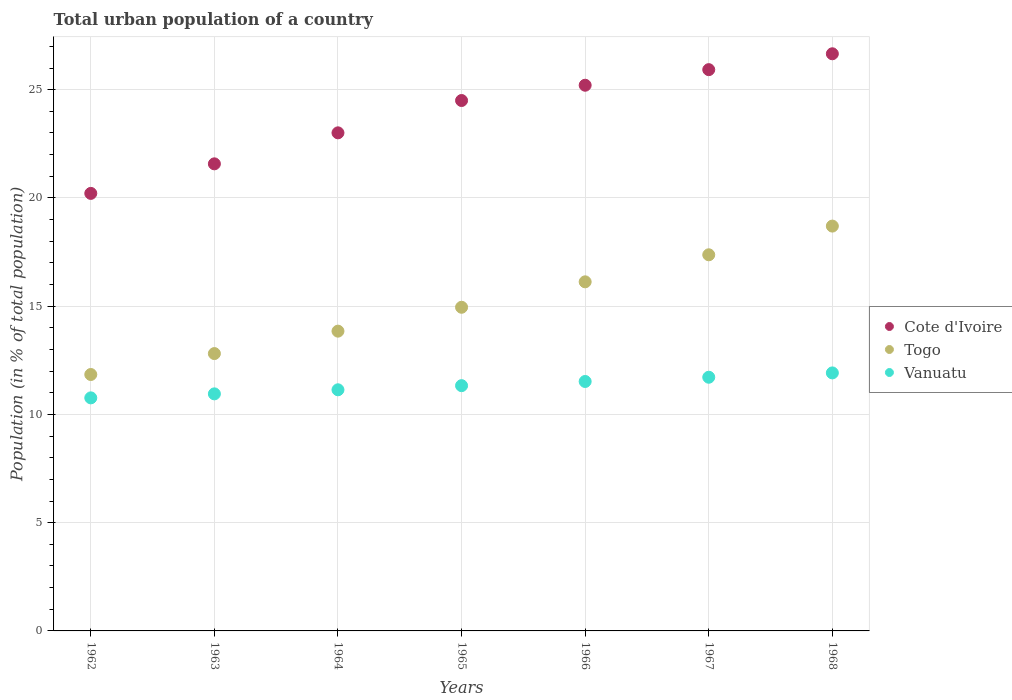Is the number of dotlines equal to the number of legend labels?
Provide a succinct answer. Yes. What is the urban population in Vanuatu in 1968?
Your answer should be compact. 11.92. Across all years, what is the maximum urban population in Togo?
Ensure brevity in your answer.  18.7. Across all years, what is the minimum urban population in Cote d'Ivoire?
Offer a very short reply. 20.21. In which year was the urban population in Cote d'Ivoire maximum?
Your answer should be very brief. 1968. What is the total urban population in Togo in the graph?
Keep it short and to the point. 105.65. What is the difference between the urban population in Vanuatu in 1965 and that in 1967?
Ensure brevity in your answer.  -0.39. What is the difference between the urban population in Vanuatu in 1966 and the urban population in Cote d'Ivoire in 1963?
Provide a succinct answer. -10.05. What is the average urban population in Togo per year?
Provide a succinct answer. 15.09. In the year 1963, what is the difference between the urban population in Togo and urban population in Cote d'Ivoire?
Keep it short and to the point. -8.76. In how many years, is the urban population in Togo greater than 7 %?
Offer a very short reply. 7. What is the ratio of the urban population in Togo in 1964 to that in 1965?
Offer a terse response. 0.93. What is the difference between the highest and the second highest urban population in Vanuatu?
Give a very brief answer. 0.2. What is the difference between the highest and the lowest urban population in Vanuatu?
Ensure brevity in your answer.  1.15. Is the sum of the urban population in Cote d'Ivoire in 1962 and 1963 greater than the maximum urban population in Vanuatu across all years?
Give a very brief answer. Yes. Does the urban population in Vanuatu monotonically increase over the years?
Keep it short and to the point. Yes. How many years are there in the graph?
Provide a succinct answer. 7. What is the difference between two consecutive major ticks on the Y-axis?
Make the answer very short. 5. Where does the legend appear in the graph?
Offer a terse response. Center right. How many legend labels are there?
Offer a very short reply. 3. What is the title of the graph?
Offer a very short reply. Total urban population of a country. Does "Cayman Islands" appear as one of the legend labels in the graph?
Your answer should be compact. No. What is the label or title of the Y-axis?
Offer a very short reply. Population (in % of total population). What is the Population (in % of total population) of Cote d'Ivoire in 1962?
Offer a very short reply. 20.21. What is the Population (in % of total population) in Togo in 1962?
Ensure brevity in your answer.  11.84. What is the Population (in % of total population) of Vanuatu in 1962?
Provide a short and direct response. 10.77. What is the Population (in % of total population) of Cote d'Ivoire in 1963?
Offer a terse response. 21.57. What is the Population (in % of total population) in Togo in 1963?
Offer a terse response. 12.81. What is the Population (in % of total population) of Vanuatu in 1963?
Your response must be concise. 10.95. What is the Population (in % of total population) of Cote d'Ivoire in 1964?
Your answer should be compact. 23.01. What is the Population (in % of total population) of Togo in 1964?
Your answer should be compact. 13.85. What is the Population (in % of total population) in Vanuatu in 1964?
Your response must be concise. 11.14. What is the Population (in % of total population) of Togo in 1965?
Ensure brevity in your answer.  14.95. What is the Population (in % of total population) of Vanuatu in 1965?
Your answer should be very brief. 11.33. What is the Population (in % of total population) of Cote d'Ivoire in 1966?
Give a very brief answer. 25.21. What is the Population (in % of total population) in Togo in 1966?
Provide a short and direct response. 16.12. What is the Population (in % of total population) of Vanuatu in 1966?
Offer a terse response. 11.52. What is the Population (in % of total population) of Cote d'Ivoire in 1967?
Provide a short and direct response. 25.93. What is the Population (in % of total population) of Togo in 1967?
Ensure brevity in your answer.  17.37. What is the Population (in % of total population) in Vanuatu in 1967?
Ensure brevity in your answer.  11.72. What is the Population (in % of total population) in Cote d'Ivoire in 1968?
Make the answer very short. 26.66. What is the Population (in % of total population) in Vanuatu in 1968?
Provide a succinct answer. 11.92. Across all years, what is the maximum Population (in % of total population) in Cote d'Ivoire?
Ensure brevity in your answer.  26.66. Across all years, what is the maximum Population (in % of total population) in Togo?
Offer a terse response. 18.7. Across all years, what is the maximum Population (in % of total population) in Vanuatu?
Give a very brief answer. 11.92. Across all years, what is the minimum Population (in % of total population) of Cote d'Ivoire?
Your answer should be compact. 20.21. Across all years, what is the minimum Population (in % of total population) of Togo?
Your answer should be compact. 11.84. Across all years, what is the minimum Population (in % of total population) of Vanuatu?
Offer a terse response. 10.77. What is the total Population (in % of total population) of Cote d'Ivoire in the graph?
Give a very brief answer. 167.08. What is the total Population (in % of total population) in Togo in the graph?
Provide a short and direct response. 105.65. What is the total Population (in % of total population) of Vanuatu in the graph?
Keep it short and to the point. 79.34. What is the difference between the Population (in % of total population) of Cote d'Ivoire in 1962 and that in 1963?
Give a very brief answer. -1.36. What is the difference between the Population (in % of total population) in Togo in 1962 and that in 1963?
Your answer should be compact. -0.97. What is the difference between the Population (in % of total population) of Vanuatu in 1962 and that in 1963?
Give a very brief answer. -0.18. What is the difference between the Population (in % of total population) in Cote d'Ivoire in 1962 and that in 1964?
Your response must be concise. -2.8. What is the difference between the Population (in % of total population) in Togo in 1962 and that in 1964?
Provide a succinct answer. -2. What is the difference between the Population (in % of total population) in Vanuatu in 1962 and that in 1964?
Your response must be concise. -0.37. What is the difference between the Population (in % of total population) in Cote d'Ivoire in 1962 and that in 1965?
Your response must be concise. -4.29. What is the difference between the Population (in % of total population) in Togo in 1962 and that in 1965?
Your answer should be compact. -3.11. What is the difference between the Population (in % of total population) in Vanuatu in 1962 and that in 1965?
Make the answer very short. -0.56. What is the difference between the Population (in % of total population) in Cote d'Ivoire in 1962 and that in 1966?
Provide a succinct answer. -5. What is the difference between the Population (in % of total population) in Togo in 1962 and that in 1966?
Make the answer very short. -4.28. What is the difference between the Population (in % of total population) of Vanuatu in 1962 and that in 1966?
Provide a short and direct response. -0.76. What is the difference between the Population (in % of total population) in Cote d'Ivoire in 1962 and that in 1967?
Make the answer very short. -5.72. What is the difference between the Population (in % of total population) in Togo in 1962 and that in 1967?
Offer a terse response. -5.53. What is the difference between the Population (in % of total population) in Vanuatu in 1962 and that in 1967?
Offer a terse response. -0.95. What is the difference between the Population (in % of total population) in Cote d'Ivoire in 1962 and that in 1968?
Keep it short and to the point. -6.45. What is the difference between the Population (in % of total population) of Togo in 1962 and that in 1968?
Your answer should be very brief. -6.86. What is the difference between the Population (in % of total population) in Vanuatu in 1962 and that in 1968?
Offer a very short reply. -1.15. What is the difference between the Population (in % of total population) of Cote d'Ivoire in 1963 and that in 1964?
Make the answer very short. -1.43. What is the difference between the Population (in % of total population) in Togo in 1963 and that in 1964?
Offer a very short reply. -1.04. What is the difference between the Population (in % of total population) in Vanuatu in 1963 and that in 1964?
Provide a succinct answer. -0.19. What is the difference between the Population (in % of total population) of Cote d'Ivoire in 1963 and that in 1965?
Give a very brief answer. -2.92. What is the difference between the Population (in % of total population) of Togo in 1963 and that in 1965?
Your response must be concise. -2.14. What is the difference between the Population (in % of total population) of Vanuatu in 1963 and that in 1965?
Offer a very short reply. -0.38. What is the difference between the Population (in % of total population) in Cote d'Ivoire in 1963 and that in 1966?
Provide a succinct answer. -3.63. What is the difference between the Population (in % of total population) of Togo in 1963 and that in 1966?
Offer a very short reply. -3.31. What is the difference between the Population (in % of total population) of Vanuatu in 1963 and that in 1966?
Ensure brevity in your answer.  -0.57. What is the difference between the Population (in % of total population) in Cote d'Ivoire in 1963 and that in 1967?
Provide a succinct answer. -4.35. What is the difference between the Population (in % of total population) in Togo in 1963 and that in 1967?
Ensure brevity in your answer.  -4.56. What is the difference between the Population (in % of total population) of Vanuatu in 1963 and that in 1967?
Ensure brevity in your answer.  -0.77. What is the difference between the Population (in % of total population) in Cote d'Ivoire in 1963 and that in 1968?
Make the answer very short. -5.08. What is the difference between the Population (in % of total population) of Togo in 1963 and that in 1968?
Provide a succinct answer. -5.89. What is the difference between the Population (in % of total population) in Vanuatu in 1963 and that in 1968?
Provide a short and direct response. -0.97. What is the difference between the Population (in % of total population) in Cote d'Ivoire in 1964 and that in 1965?
Keep it short and to the point. -1.49. What is the difference between the Population (in % of total population) of Togo in 1964 and that in 1965?
Offer a very short reply. -1.1. What is the difference between the Population (in % of total population) of Vanuatu in 1964 and that in 1965?
Your answer should be compact. -0.19. What is the difference between the Population (in % of total population) in Cote d'Ivoire in 1964 and that in 1966?
Your response must be concise. -2.2. What is the difference between the Population (in % of total population) of Togo in 1964 and that in 1966?
Your response must be concise. -2.28. What is the difference between the Population (in % of total population) of Vanuatu in 1964 and that in 1966?
Offer a very short reply. -0.38. What is the difference between the Population (in % of total population) of Cote d'Ivoire in 1964 and that in 1967?
Give a very brief answer. -2.92. What is the difference between the Population (in % of total population) in Togo in 1964 and that in 1967?
Provide a short and direct response. -3.53. What is the difference between the Population (in % of total population) in Vanuatu in 1964 and that in 1967?
Keep it short and to the point. -0.58. What is the difference between the Population (in % of total population) in Cote d'Ivoire in 1964 and that in 1968?
Offer a very short reply. -3.65. What is the difference between the Population (in % of total population) in Togo in 1964 and that in 1968?
Your answer should be very brief. -4.85. What is the difference between the Population (in % of total population) of Vanuatu in 1964 and that in 1968?
Your answer should be very brief. -0.78. What is the difference between the Population (in % of total population) of Cote d'Ivoire in 1965 and that in 1966?
Ensure brevity in your answer.  -0.71. What is the difference between the Population (in % of total population) of Togo in 1965 and that in 1966?
Offer a very short reply. -1.18. What is the difference between the Population (in % of total population) of Vanuatu in 1965 and that in 1966?
Ensure brevity in your answer.  -0.19. What is the difference between the Population (in % of total population) of Cote d'Ivoire in 1965 and that in 1967?
Ensure brevity in your answer.  -1.43. What is the difference between the Population (in % of total population) in Togo in 1965 and that in 1967?
Make the answer very short. -2.42. What is the difference between the Population (in % of total population) in Vanuatu in 1965 and that in 1967?
Keep it short and to the point. -0.39. What is the difference between the Population (in % of total population) in Cote d'Ivoire in 1965 and that in 1968?
Your answer should be very brief. -2.16. What is the difference between the Population (in % of total population) of Togo in 1965 and that in 1968?
Provide a succinct answer. -3.75. What is the difference between the Population (in % of total population) in Vanuatu in 1965 and that in 1968?
Your answer should be very brief. -0.59. What is the difference between the Population (in % of total population) in Cote d'Ivoire in 1966 and that in 1967?
Provide a short and direct response. -0.72. What is the difference between the Population (in % of total population) of Togo in 1966 and that in 1967?
Provide a succinct answer. -1.25. What is the difference between the Population (in % of total population) of Vanuatu in 1966 and that in 1967?
Provide a succinct answer. -0.2. What is the difference between the Population (in % of total population) of Cote d'Ivoire in 1966 and that in 1968?
Give a very brief answer. -1.45. What is the difference between the Population (in % of total population) of Togo in 1966 and that in 1968?
Provide a short and direct response. -2.58. What is the difference between the Population (in % of total population) of Vanuatu in 1966 and that in 1968?
Your response must be concise. -0.4. What is the difference between the Population (in % of total population) of Cote d'Ivoire in 1967 and that in 1968?
Make the answer very short. -0.73. What is the difference between the Population (in % of total population) in Togo in 1967 and that in 1968?
Ensure brevity in your answer.  -1.33. What is the difference between the Population (in % of total population) in Vanuatu in 1967 and that in 1968?
Make the answer very short. -0.2. What is the difference between the Population (in % of total population) in Cote d'Ivoire in 1962 and the Population (in % of total population) in Togo in 1963?
Your response must be concise. 7.4. What is the difference between the Population (in % of total population) of Cote d'Ivoire in 1962 and the Population (in % of total population) of Vanuatu in 1963?
Make the answer very short. 9.26. What is the difference between the Population (in % of total population) in Togo in 1962 and the Population (in % of total population) in Vanuatu in 1963?
Your answer should be compact. 0.89. What is the difference between the Population (in % of total population) of Cote d'Ivoire in 1962 and the Population (in % of total population) of Togo in 1964?
Give a very brief answer. 6.36. What is the difference between the Population (in % of total population) of Cote d'Ivoire in 1962 and the Population (in % of total population) of Vanuatu in 1964?
Offer a terse response. 9.07. What is the difference between the Population (in % of total population) in Togo in 1962 and the Population (in % of total population) in Vanuatu in 1964?
Provide a succinct answer. 0.71. What is the difference between the Population (in % of total population) of Cote d'Ivoire in 1962 and the Population (in % of total population) of Togo in 1965?
Offer a very short reply. 5.26. What is the difference between the Population (in % of total population) in Cote d'Ivoire in 1962 and the Population (in % of total population) in Vanuatu in 1965?
Provide a succinct answer. 8.88. What is the difference between the Population (in % of total population) in Togo in 1962 and the Population (in % of total population) in Vanuatu in 1965?
Make the answer very short. 0.52. What is the difference between the Population (in % of total population) in Cote d'Ivoire in 1962 and the Population (in % of total population) in Togo in 1966?
Ensure brevity in your answer.  4.08. What is the difference between the Population (in % of total population) of Cote d'Ivoire in 1962 and the Population (in % of total population) of Vanuatu in 1966?
Your response must be concise. 8.69. What is the difference between the Population (in % of total population) in Togo in 1962 and the Population (in % of total population) in Vanuatu in 1966?
Ensure brevity in your answer.  0.32. What is the difference between the Population (in % of total population) in Cote d'Ivoire in 1962 and the Population (in % of total population) in Togo in 1967?
Give a very brief answer. 2.84. What is the difference between the Population (in % of total population) in Cote d'Ivoire in 1962 and the Population (in % of total population) in Vanuatu in 1967?
Your answer should be compact. 8.49. What is the difference between the Population (in % of total population) in Togo in 1962 and the Population (in % of total population) in Vanuatu in 1967?
Provide a succinct answer. 0.13. What is the difference between the Population (in % of total population) of Cote d'Ivoire in 1962 and the Population (in % of total population) of Togo in 1968?
Offer a terse response. 1.51. What is the difference between the Population (in % of total population) in Cote d'Ivoire in 1962 and the Population (in % of total population) in Vanuatu in 1968?
Your response must be concise. 8.29. What is the difference between the Population (in % of total population) in Togo in 1962 and the Population (in % of total population) in Vanuatu in 1968?
Offer a terse response. -0.07. What is the difference between the Population (in % of total population) of Cote d'Ivoire in 1963 and the Population (in % of total population) of Togo in 1964?
Your answer should be compact. 7.73. What is the difference between the Population (in % of total population) in Cote d'Ivoire in 1963 and the Population (in % of total population) in Vanuatu in 1964?
Make the answer very short. 10.44. What is the difference between the Population (in % of total population) of Togo in 1963 and the Population (in % of total population) of Vanuatu in 1964?
Offer a very short reply. 1.67. What is the difference between the Population (in % of total population) in Cote d'Ivoire in 1963 and the Population (in % of total population) in Togo in 1965?
Keep it short and to the point. 6.62. What is the difference between the Population (in % of total population) of Cote d'Ivoire in 1963 and the Population (in % of total population) of Vanuatu in 1965?
Offer a terse response. 10.25. What is the difference between the Population (in % of total population) of Togo in 1963 and the Population (in % of total population) of Vanuatu in 1965?
Offer a terse response. 1.48. What is the difference between the Population (in % of total population) in Cote d'Ivoire in 1963 and the Population (in % of total population) in Togo in 1966?
Keep it short and to the point. 5.45. What is the difference between the Population (in % of total population) of Cote d'Ivoire in 1963 and the Population (in % of total population) of Vanuatu in 1966?
Keep it short and to the point. 10.05. What is the difference between the Population (in % of total population) of Togo in 1963 and the Population (in % of total population) of Vanuatu in 1966?
Provide a short and direct response. 1.29. What is the difference between the Population (in % of total population) of Cote d'Ivoire in 1963 and the Population (in % of total population) of Togo in 1967?
Your answer should be compact. 4.2. What is the difference between the Population (in % of total population) of Cote d'Ivoire in 1963 and the Population (in % of total population) of Vanuatu in 1967?
Give a very brief answer. 9.86. What is the difference between the Population (in % of total population) in Togo in 1963 and the Population (in % of total population) in Vanuatu in 1967?
Your answer should be very brief. 1.09. What is the difference between the Population (in % of total population) of Cote d'Ivoire in 1963 and the Population (in % of total population) of Togo in 1968?
Your answer should be compact. 2.88. What is the difference between the Population (in % of total population) of Cote d'Ivoire in 1963 and the Population (in % of total population) of Vanuatu in 1968?
Keep it short and to the point. 9.66. What is the difference between the Population (in % of total population) of Togo in 1963 and the Population (in % of total population) of Vanuatu in 1968?
Your answer should be compact. 0.89. What is the difference between the Population (in % of total population) of Cote d'Ivoire in 1964 and the Population (in % of total population) of Togo in 1965?
Your answer should be compact. 8.06. What is the difference between the Population (in % of total population) in Cote d'Ivoire in 1964 and the Population (in % of total population) in Vanuatu in 1965?
Provide a succinct answer. 11.68. What is the difference between the Population (in % of total population) in Togo in 1964 and the Population (in % of total population) in Vanuatu in 1965?
Provide a short and direct response. 2.52. What is the difference between the Population (in % of total population) of Cote d'Ivoire in 1964 and the Population (in % of total population) of Togo in 1966?
Keep it short and to the point. 6.88. What is the difference between the Population (in % of total population) of Cote d'Ivoire in 1964 and the Population (in % of total population) of Vanuatu in 1966?
Keep it short and to the point. 11.48. What is the difference between the Population (in % of total population) in Togo in 1964 and the Population (in % of total population) in Vanuatu in 1966?
Your response must be concise. 2.33. What is the difference between the Population (in % of total population) of Cote d'Ivoire in 1964 and the Population (in % of total population) of Togo in 1967?
Your answer should be compact. 5.63. What is the difference between the Population (in % of total population) of Cote d'Ivoire in 1964 and the Population (in % of total population) of Vanuatu in 1967?
Keep it short and to the point. 11.29. What is the difference between the Population (in % of total population) in Togo in 1964 and the Population (in % of total population) in Vanuatu in 1967?
Offer a very short reply. 2.13. What is the difference between the Population (in % of total population) in Cote d'Ivoire in 1964 and the Population (in % of total population) in Togo in 1968?
Your response must be concise. 4.31. What is the difference between the Population (in % of total population) in Cote d'Ivoire in 1964 and the Population (in % of total population) in Vanuatu in 1968?
Provide a succinct answer. 11.09. What is the difference between the Population (in % of total population) in Togo in 1964 and the Population (in % of total population) in Vanuatu in 1968?
Your answer should be compact. 1.93. What is the difference between the Population (in % of total population) of Cote d'Ivoire in 1965 and the Population (in % of total population) of Togo in 1966?
Give a very brief answer. 8.38. What is the difference between the Population (in % of total population) of Cote d'Ivoire in 1965 and the Population (in % of total population) of Vanuatu in 1966?
Your answer should be very brief. 12.98. What is the difference between the Population (in % of total population) in Togo in 1965 and the Population (in % of total population) in Vanuatu in 1966?
Keep it short and to the point. 3.43. What is the difference between the Population (in % of total population) of Cote d'Ivoire in 1965 and the Population (in % of total population) of Togo in 1967?
Your answer should be very brief. 7.13. What is the difference between the Population (in % of total population) in Cote d'Ivoire in 1965 and the Population (in % of total population) in Vanuatu in 1967?
Give a very brief answer. 12.78. What is the difference between the Population (in % of total population) in Togo in 1965 and the Population (in % of total population) in Vanuatu in 1967?
Make the answer very short. 3.23. What is the difference between the Population (in % of total population) of Cote d'Ivoire in 1965 and the Population (in % of total population) of Vanuatu in 1968?
Offer a terse response. 12.58. What is the difference between the Population (in % of total population) of Togo in 1965 and the Population (in % of total population) of Vanuatu in 1968?
Give a very brief answer. 3.03. What is the difference between the Population (in % of total population) of Cote d'Ivoire in 1966 and the Population (in % of total population) of Togo in 1967?
Make the answer very short. 7.83. What is the difference between the Population (in % of total population) of Cote d'Ivoire in 1966 and the Population (in % of total population) of Vanuatu in 1967?
Give a very brief answer. 13.49. What is the difference between the Population (in % of total population) in Togo in 1966 and the Population (in % of total population) in Vanuatu in 1967?
Ensure brevity in your answer.  4.41. What is the difference between the Population (in % of total population) of Cote d'Ivoire in 1966 and the Population (in % of total population) of Togo in 1968?
Give a very brief answer. 6.51. What is the difference between the Population (in % of total population) in Cote d'Ivoire in 1966 and the Population (in % of total population) in Vanuatu in 1968?
Provide a succinct answer. 13.29. What is the difference between the Population (in % of total population) of Togo in 1966 and the Population (in % of total population) of Vanuatu in 1968?
Make the answer very short. 4.21. What is the difference between the Population (in % of total population) in Cote d'Ivoire in 1967 and the Population (in % of total population) in Togo in 1968?
Offer a very short reply. 7.23. What is the difference between the Population (in % of total population) of Cote d'Ivoire in 1967 and the Population (in % of total population) of Vanuatu in 1968?
Provide a short and direct response. 14.01. What is the difference between the Population (in % of total population) in Togo in 1967 and the Population (in % of total population) in Vanuatu in 1968?
Your answer should be very brief. 5.46. What is the average Population (in % of total population) of Cote d'Ivoire per year?
Your answer should be compact. 23.87. What is the average Population (in % of total population) in Togo per year?
Offer a very short reply. 15.09. What is the average Population (in % of total population) of Vanuatu per year?
Provide a succinct answer. 11.33. In the year 1962, what is the difference between the Population (in % of total population) of Cote d'Ivoire and Population (in % of total population) of Togo?
Make the answer very short. 8.37. In the year 1962, what is the difference between the Population (in % of total population) in Cote d'Ivoire and Population (in % of total population) in Vanuatu?
Provide a succinct answer. 9.45. In the year 1962, what is the difference between the Population (in % of total population) in Togo and Population (in % of total population) in Vanuatu?
Your answer should be compact. 1.08. In the year 1963, what is the difference between the Population (in % of total population) of Cote d'Ivoire and Population (in % of total population) of Togo?
Provide a short and direct response. 8.76. In the year 1963, what is the difference between the Population (in % of total population) in Cote d'Ivoire and Population (in % of total population) in Vanuatu?
Offer a terse response. 10.62. In the year 1963, what is the difference between the Population (in % of total population) in Togo and Population (in % of total population) in Vanuatu?
Provide a succinct answer. 1.86. In the year 1964, what is the difference between the Population (in % of total population) in Cote d'Ivoire and Population (in % of total population) in Togo?
Provide a succinct answer. 9.16. In the year 1964, what is the difference between the Population (in % of total population) in Cote d'Ivoire and Population (in % of total population) in Vanuatu?
Your answer should be compact. 11.87. In the year 1964, what is the difference between the Population (in % of total population) of Togo and Population (in % of total population) of Vanuatu?
Provide a short and direct response. 2.71. In the year 1965, what is the difference between the Population (in % of total population) of Cote d'Ivoire and Population (in % of total population) of Togo?
Offer a very short reply. 9.55. In the year 1965, what is the difference between the Population (in % of total population) of Cote d'Ivoire and Population (in % of total population) of Vanuatu?
Ensure brevity in your answer.  13.17. In the year 1965, what is the difference between the Population (in % of total population) of Togo and Population (in % of total population) of Vanuatu?
Your answer should be compact. 3.62. In the year 1966, what is the difference between the Population (in % of total population) in Cote d'Ivoire and Population (in % of total population) in Togo?
Offer a terse response. 9.08. In the year 1966, what is the difference between the Population (in % of total population) of Cote d'Ivoire and Population (in % of total population) of Vanuatu?
Your answer should be very brief. 13.68. In the year 1966, what is the difference between the Population (in % of total population) in Togo and Population (in % of total population) in Vanuatu?
Give a very brief answer. 4.6. In the year 1967, what is the difference between the Population (in % of total population) of Cote d'Ivoire and Population (in % of total population) of Togo?
Ensure brevity in your answer.  8.55. In the year 1967, what is the difference between the Population (in % of total population) in Cote d'Ivoire and Population (in % of total population) in Vanuatu?
Provide a short and direct response. 14.21. In the year 1967, what is the difference between the Population (in % of total population) in Togo and Population (in % of total population) in Vanuatu?
Your answer should be very brief. 5.66. In the year 1968, what is the difference between the Population (in % of total population) in Cote d'Ivoire and Population (in % of total population) in Togo?
Your answer should be very brief. 7.96. In the year 1968, what is the difference between the Population (in % of total population) in Cote d'Ivoire and Population (in % of total population) in Vanuatu?
Your answer should be compact. 14.74. In the year 1968, what is the difference between the Population (in % of total population) of Togo and Population (in % of total population) of Vanuatu?
Offer a terse response. 6.78. What is the ratio of the Population (in % of total population) in Cote d'Ivoire in 1962 to that in 1963?
Provide a succinct answer. 0.94. What is the ratio of the Population (in % of total population) of Togo in 1962 to that in 1963?
Give a very brief answer. 0.92. What is the ratio of the Population (in % of total population) in Vanuatu in 1962 to that in 1963?
Make the answer very short. 0.98. What is the ratio of the Population (in % of total population) of Cote d'Ivoire in 1962 to that in 1964?
Provide a succinct answer. 0.88. What is the ratio of the Population (in % of total population) in Togo in 1962 to that in 1964?
Make the answer very short. 0.86. What is the ratio of the Population (in % of total population) in Vanuatu in 1962 to that in 1964?
Offer a very short reply. 0.97. What is the ratio of the Population (in % of total population) in Cote d'Ivoire in 1962 to that in 1965?
Ensure brevity in your answer.  0.82. What is the ratio of the Population (in % of total population) in Togo in 1962 to that in 1965?
Offer a very short reply. 0.79. What is the ratio of the Population (in % of total population) of Vanuatu in 1962 to that in 1965?
Keep it short and to the point. 0.95. What is the ratio of the Population (in % of total population) in Cote d'Ivoire in 1962 to that in 1966?
Provide a succinct answer. 0.8. What is the ratio of the Population (in % of total population) in Togo in 1962 to that in 1966?
Provide a succinct answer. 0.73. What is the ratio of the Population (in % of total population) in Vanuatu in 1962 to that in 1966?
Provide a succinct answer. 0.93. What is the ratio of the Population (in % of total population) in Cote d'Ivoire in 1962 to that in 1967?
Your answer should be very brief. 0.78. What is the ratio of the Population (in % of total population) in Togo in 1962 to that in 1967?
Offer a terse response. 0.68. What is the ratio of the Population (in % of total population) of Vanuatu in 1962 to that in 1967?
Your response must be concise. 0.92. What is the ratio of the Population (in % of total population) in Cote d'Ivoire in 1962 to that in 1968?
Your answer should be compact. 0.76. What is the ratio of the Population (in % of total population) in Togo in 1962 to that in 1968?
Provide a succinct answer. 0.63. What is the ratio of the Population (in % of total population) of Vanuatu in 1962 to that in 1968?
Your response must be concise. 0.9. What is the ratio of the Population (in % of total population) in Cote d'Ivoire in 1963 to that in 1964?
Give a very brief answer. 0.94. What is the ratio of the Population (in % of total population) of Togo in 1963 to that in 1964?
Your answer should be compact. 0.93. What is the ratio of the Population (in % of total population) of Vanuatu in 1963 to that in 1964?
Provide a succinct answer. 0.98. What is the ratio of the Population (in % of total population) of Cote d'Ivoire in 1963 to that in 1965?
Ensure brevity in your answer.  0.88. What is the ratio of the Population (in % of total population) of Togo in 1963 to that in 1965?
Your answer should be compact. 0.86. What is the ratio of the Population (in % of total population) of Vanuatu in 1963 to that in 1965?
Make the answer very short. 0.97. What is the ratio of the Population (in % of total population) in Cote d'Ivoire in 1963 to that in 1966?
Provide a succinct answer. 0.86. What is the ratio of the Population (in % of total population) in Togo in 1963 to that in 1966?
Provide a short and direct response. 0.79. What is the ratio of the Population (in % of total population) of Vanuatu in 1963 to that in 1966?
Offer a very short reply. 0.95. What is the ratio of the Population (in % of total population) in Cote d'Ivoire in 1963 to that in 1967?
Your response must be concise. 0.83. What is the ratio of the Population (in % of total population) in Togo in 1963 to that in 1967?
Give a very brief answer. 0.74. What is the ratio of the Population (in % of total population) in Vanuatu in 1963 to that in 1967?
Provide a short and direct response. 0.93. What is the ratio of the Population (in % of total population) of Cote d'Ivoire in 1963 to that in 1968?
Give a very brief answer. 0.81. What is the ratio of the Population (in % of total population) in Togo in 1963 to that in 1968?
Ensure brevity in your answer.  0.69. What is the ratio of the Population (in % of total population) in Vanuatu in 1963 to that in 1968?
Your response must be concise. 0.92. What is the ratio of the Population (in % of total population) in Cote d'Ivoire in 1964 to that in 1965?
Make the answer very short. 0.94. What is the ratio of the Population (in % of total population) of Togo in 1964 to that in 1965?
Offer a terse response. 0.93. What is the ratio of the Population (in % of total population) in Vanuatu in 1964 to that in 1965?
Give a very brief answer. 0.98. What is the ratio of the Population (in % of total population) in Cote d'Ivoire in 1964 to that in 1966?
Your answer should be very brief. 0.91. What is the ratio of the Population (in % of total population) in Togo in 1964 to that in 1966?
Make the answer very short. 0.86. What is the ratio of the Population (in % of total population) in Vanuatu in 1964 to that in 1966?
Provide a succinct answer. 0.97. What is the ratio of the Population (in % of total population) in Cote d'Ivoire in 1964 to that in 1967?
Your response must be concise. 0.89. What is the ratio of the Population (in % of total population) of Togo in 1964 to that in 1967?
Offer a very short reply. 0.8. What is the ratio of the Population (in % of total population) in Vanuatu in 1964 to that in 1967?
Your answer should be compact. 0.95. What is the ratio of the Population (in % of total population) in Cote d'Ivoire in 1964 to that in 1968?
Keep it short and to the point. 0.86. What is the ratio of the Population (in % of total population) in Togo in 1964 to that in 1968?
Give a very brief answer. 0.74. What is the ratio of the Population (in % of total population) in Vanuatu in 1964 to that in 1968?
Give a very brief answer. 0.93. What is the ratio of the Population (in % of total population) in Cote d'Ivoire in 1965 to that in 1966?
Ensure brevity in your answer.  0.97. What is the ratio of the Population (in % of total population) in Togo in 1965 to that in 1966?
Your response must be concise. 0.93. What is the ratio of the Population (in % of total population) of Vanuatu in 1965 to that in 1966?
Offer a terse response. 0.98. What is the ratio of the Population (in % of total population) of Cote d'Ivoire in 1965 to that in 1967?
Provide a short and direct response. 0.94. What is the ratio of the Population (in % of total population) in Togo in 1965 to that in 1967?
Ensure brevity in your answer.  0.86. What is the ratio of the Population (in % of total population) of Vanuatu in 1965 to that in 1967?
Provide a short and direct response. 0.97. What is the ratio of the Population (in % of total population) of Cote d'Ivoire in 1965 to that in 1968?
Your answer should be very brief. 0.92. What is the ratio of the Population (in % of total population) of Togo in 1965 to that in 1968?
Provide a short and direct response. 0.8. What is the ratio of the Population (in % of total population) in Vanuatu in 1965 to that in 1968?
Keep it short and to the point. 0.95. What is the ratio of the Population (in % of total population) of Cote d'Ivoire in 1966 to that in 1967?
Ensure brevity in your answer.  0.97. What is the ratio of the Population (in % of total population) of Togo in 1966 to that in 1967?
Your answer should be very brief. 0.93. What is the ratio of the Population (in % of total population) in Vanuatu in 1966 to that in 1967?
Give a very brief answer. 0.98. What is the ratio of the Population (in % of total population) of Cote d'Ivoire in 1966 to that in 1968?
Your answer should be compact. 0.95. What is the ratio of the Population (in % of total population) in Togo in 1966 to that in 1968?
Your answer should be very brief. 0.86. What is the ratio of the Population (in % of total population) in Vanuatu in 1966 to that in 1968?
Give a very brief answer. 0.97. What is the ratio of the Population (in % of total population) in Cote d'Ivoire in 1967 to that in 1968?
Offer a terse response. 0.97. What is the ratio of the Population (in % of total population) in Togo in 1967 to that in 1968?
Ensure brevity in your answer.  0.93. What is the ratio of the Population (in % of total population) in Vanuatu in 1967 to that in 1968?
Ensure brevity in your answer.  0.98. What is the difference between the highest and the second highest Population (in % of total population) of Cote d'Ivoire?
Your answer should be very brief. 0.73. What is the difference between the highest and the second highest Population (in % of total population) of Togo?
Offer a very short reply. 1.33. What is the difference between the highest and the second highest Population (in % of total population) in Vanuatu?
Keep it short and to the point. 0.2. What is the difference between the highest and the lowest Population (in % of total population) in Cote d'Ivoire?
Offer a terse response. 6.45. What is the difference between the highest and the lowest Population (in % of total population) of Togo?
Your response must be concise. 6.86. What is the difference between the highest and the lowest Population (in % of total population) in Vanuatu?
Ensure brevity in your answer.  1.15. 